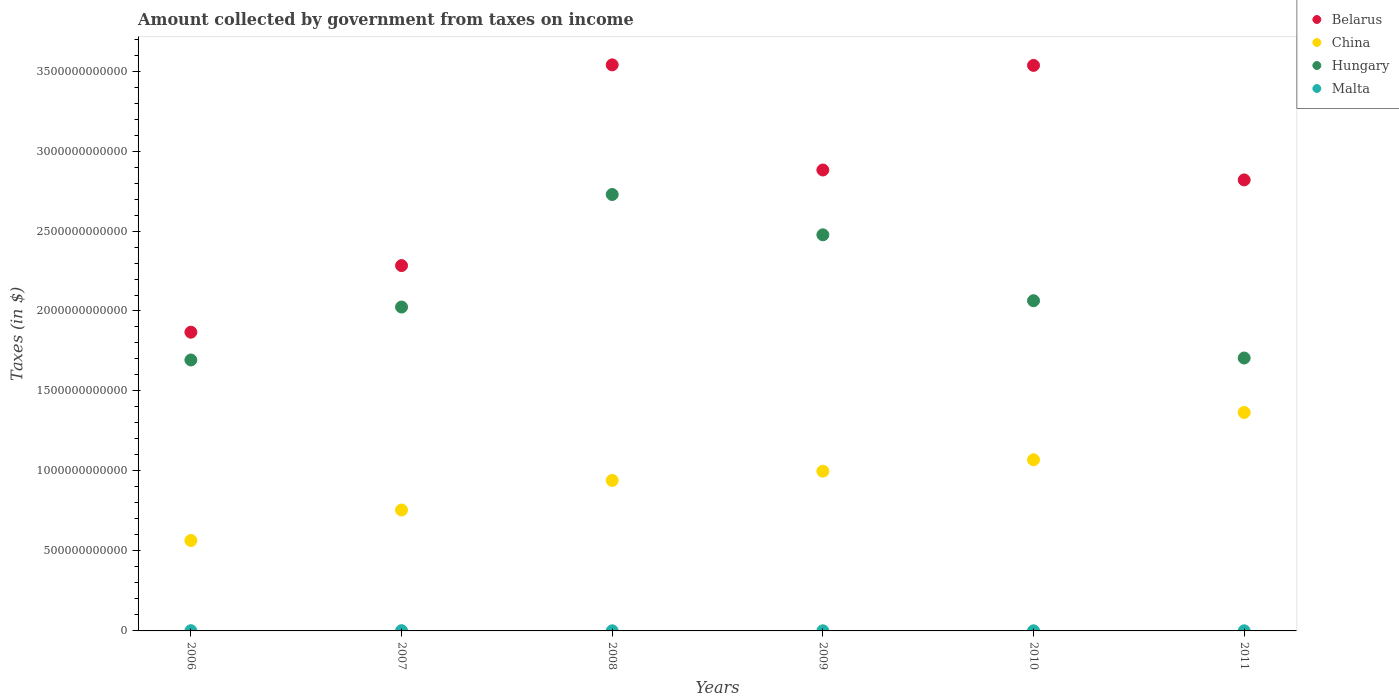What is the amount collected by government from taxes on income in Hungary in 2008?
Your answer should be very brief. 2.73e+12. Across all years, what is the maximum amount collected by government from taxes on income in Hungary?
Provide a succinct answer. 2.73e+12. Across all years, what is the minimum amount collected by government from taxes on income in Hungary?
Your answer should be very brief. 1.69e+12. In which year was the amount collected by government from taxes on income in Belarus minimum?
Your answer should be very brief. 2006. What is the total amount collected by government from taxes on income in Malta in the graph?
Offer a very short reply. 6.03e+09. What is the difference between the amount collected by government from taxes on income in China in 2006 and that in 2008?
Provide a short and direct response. -3.76e+11. What is the difference between the amount collected by government from taxes on income in Hungary in 2011 and the amount collected by government from taxes on income in China in 2008?
Offer a very short reply. 7.65e+11. What is the average amount collected by government from taxes on income in China per year?
Your answer should be compact. 9.49e+11. In the year 2006, what is the difference between the amount collected by government from taxes on income in Malta and amount collected by government from taxes on income in Belarus?
Offer a terse response. -1.87e+12. What is the ratio of the amount collected by government from taxes on income in Hungary in 2006 to that in 2011?
Your answer should be compact. 0.99. Is the difference between the amount collected by government from taxes on income in Malta in 2007 and 2010 greater than the difference between the amount collected by government from taxes on income in Belarus in 2007 and 2010?
Give a very brief answer. Yes. What is the difference between the highest and the second highest amount collected by government from taxes on income in Belarus?
Your response must be concise. 3.34e+09. What is the difference between the highest and the lowest amount collected by government from taxes on income in China?
Your answer should be very brief. 8.00e+11. Is the sum of the amount collected by government from taxes on income in Malta in 2007 and 2010 greater than the maximum amount collected by government from taxes on income in Belarus across all years?
Offer a very short reply. No. Is the amount collected by government from taxes on income in Hungary strictly less than the amount collected by government from taxes on income in Malta over the years?
Provide a short and direct response. No. How many dotlines are there?
Keep it short and to the point. 4. What is the difference between two consecutive major ticks on the Y-axis?
Give a very brief answer. 5.00e+11. Does the graph contain any zero values?
Offer a terse response. No. How are the legend labels stacked?
Your response must be concise. Vertical. What is the title of the graph?
Offer a very short reply. Amount collected by government from taxes on income. Does "Middle income" appear as one of the legend labels in the graph?
Your answer should be compact. No. What is the label or title of the Y-axis?
Ensure brevity in your answer.  Taxes (in $). What is the Taxes (in $) in Belarus in 2006?
Keep it short and to the point. 1.87e+12. What is the Taxes (in $) in China in 2006?
Ensure brevity in your answer.  5.65e+11. What is the Taxes (in $) of Hungary in 2006?
Keep it short and to the point. 1.69e+12. What is the Taxes (in $) in Malta in 2006?
Your answer should be compact. 1.36e+09. What is the Taxes (in $) in Belarus in 2007?
Offer a terse response. 2.28e+12. What is the Taxes (in $) of China in 2007?
Offer a terse response. 7.56e+11. What is the Taxes (in $) in Hungary in 2007?
Your response must be concise. 2.02e+12. What is the Taxes (in $) of Malta in 2007?
Provide a succinct answer. 1.61e+09. What is the Taxes (in $) in Belarus in 2008?
Keep it short and to the point. 3.54e+12. What is the Taxes (in $) of China in 2008?
Offer a very short reply. 9.41e+11. What is the Taxes (in $) in Hungary in 2008?
Ensure brevity in your answer.  2.73e+12. What is the Taxes (in $) of Malta in 2008?
Make the answer very short. 7.17e+08. What is the Taxes (in $) of Belarus in 2009?
Keep it short and to the point. 2.88e+12. What is the Taxes (in $) of China in 2009?
Ensure brevity in your answer.  9.99e+11. What is the Taxes (in $) in Hungary in 2009?
Ensure brevity in your answer.  2.48e+12. What is the Taxes (in $) of Malta in 2009?
Offer a very short reply. 7.59e+08. What is the Taxes (in $) of Belarus in 2010?
Provide a succinct answer. 3.54e+12. What is the Taxes (in $) in China in 2010?
Make the answer very short. 1.07e+12. What is the Taxes (in $) in Hungary in 2010?
Give a very brief answer. 2.06e+12. What is the Taxes (in $) in Malta in 2010?
Your answer should be very brief. 7.70e+08. What is the Taxes (in $) in Belarus in 2011?
Make the answer very short. 2.82e+12. What is the Taxes (in $) in China in 2011?
Give a very brief answer. 1.37e+12. What is the Taxes (in $) of Hungary in 2011?
Make the answer very short. 1.71e+12. What is the Taxes (in $) of Malta in 2011?
Provide a short and direct response. 8.11e+08. Across all years, what is the maximum Taxes (in $) in Belarus?
Give a very brief answer. 3.54e+12. Across all years, what is the maximum Taxes (in $) of China?
Your answer should be very brief. 1.37e+12. Across all years, what is the maximum Taxes (in $) of Hungary?
Keep it short and to the point. 2.73e+12. Across all years, what is the maximum Taxes (in $) of Malta?
Keep it short and to the point. 1.61e+09. Across all years, what is the minimum Taxes (in $) in Belarus?
Provide a succinct answer. 1.87e+12. Across all years, what is the minimum Taxes (in $) of China?
Make the answer very short. 5.65e+11. Across all years, what is the minimum Taxes (in $) in Hungary?
Make the answer very short. 1.69e+12. Across all years, what is the minimum Taxes (in $) of Malta?
Provide a succinct answer. 7.17e+08. What is the total Taxes (in $) in Belarus in the graph?
Offer a terse response. 1.69e+13. What is the total Taxes (in $) of China in the graph?
Offer a terse response. 5.70e+12. What is the total Taxes (in $) of Hungary in the graph?
Ensure brevity in your answer.  1.27e+13. What is the total Taxes (in $) of Malta in the graph?
Keep it short and to the point. 6.03e+09. What is the difference between the Taxes (in $) of Belarus in 2006 and that in 2007?
Offer a terse response. -4.16e+11. What is the difference between the Taxes (in $) of China in 2006 and that in 2007?
Keep it short and to the point. -1.91e+11. What is the difference between the Taxes (in $) in Hungary in 2006 and that in 2007?
Give a very brief answer. -3.31e+11. What is the difference between the Taxes (in $) of Malta in 2006 and that in 2007?
Your answer should be compact. -2.51e+08. What is the difference between the Taxes (in $) of Belarus in 2006 and that in 2008?
Your response must be concise. -1.67e+12. What is the difference between the Taxes (in $) in China in 2006 and that in 2008?
Give a very brief answer. -3.76e+11. What is the difference between the Taxes (in $) in Hungary in 2006 and that in 2008?
Offer a terse response. -1.03e+12. What is the difference between the Taxes (in $) of Malta in 2006 and that in 2008?
Provide a short and direct response. 6.43e+08. What is the difference between the Taxes (in $) in Belarus in 2006 and that in 2009?
Give a very brief answer. -1.01e+12. What is the difference between the Taxes (in $) of China in 2006 and that in 2009?
Provide a short and direct response. -4.33e+11. What is the difference between the Taxes (in $) in Hungary in 2006 and that in 2009?
Offer a terse response. -7.82e+11. What is the difference between the Taxes (in $) of Malta in 2006 and that in 2009?
Your response must be concise. 6.01e+08. What is the difference between the Taxes (in $) in Belarus in 2006 and that in 2010?
Your answer should be compact. -1.67e+12. What is the difference between the Taxes (in $) of China in 2006 and that in 2010?
Your answer should be compact. -5.05e+11. What is the difference between the Taxes (in $) of Hungary in 2006 and that in 2010?
Provide a short and direct response. -3.70e+11. What is the difference between the Taxes (in $) of Malta in 2006 and that in 2010?
Ensure brevity in your answer.  5.90e+08. What is the difference between the Taxes (in $) of Belarus in 2006 and that in 2011?
Provide a short and direct response. -9.52e+11. What is the difference between the Taxes (in $) in China in 2006 and that in 2011?
Your answer should be very brief. -8.00e+11. What is the difference between the Taxes (in $) in Hungary in 2006 and that in 2011?
Provide a succinct answer. -1.23e+1. What is the difference between the Taxes (in $) in Malta in 2006 and that in 2011?
Your answer should be compact. 5.50e+08. What is the difference between the Taxes (in $) in Belarus in 2007 and that in 2008?
Your answer should be compact. -1.25e+12. What is the difference between the Taxes (in $) in China in 2007 and that in 2008?
Offer a very short reply. -1.85e+11. What is the difference between the Taxes (in $) in Hungary in 2007 and that in 2008?
Ensure brevity in your answer.  -7.04e+11. What is the difference between the Taxes (in $) of Malta in 2007 and that in 2008?
Make the answer very short. 8.94e+08. What is the difference between the Taxes (in $) of Belarus in 2007 and that in 2009?
Offer a terse response. -5.97e+11. What is the difference between the Taxes (in $) of China in 2007 and that in 2009?
Your response must be concise. -2.43e+11. What is the difference between the Taxes (in $) of Hungary in 2007 and that in 2009?
Ensure brevity in your answer.  -4.52e+11. What is the difference between the Taxes (in $) of Malta in 2007 and that in 2009?
Ensure brevity in your answer.  8.52e+08. What is the difference between the Taxes (in $) in Belarus in 2007 and that in 2010?
Your response must be concise. -1.25e+12. What is the difference between the Taxes (in $) of China in 2007 and that in 2010?
Keep it short and to the point. -3.14e+11. What is the difference between the Taxes (in $) of Hungary in 2007 and that in 2010?
Provide a short and direct response. -3.95e+1. What is the difference between the Taxes (in $) of Malta in 2007 and that in 2010?
Keep it short and to the point. 8.41e+08. What is the difference between the Taxes (in $) in Belarus in 2007 and that in 2011?
Your answer should be very brief. -5.36e+11. What is the difference between the Taxes (in $) of China in 2007 and that in 2011?
Your answer should be very brief. -6.10e+11. What is the difference between the Taxes (in $) of Hungary in 2007 and that in 2011?
Offer a very short reply. 3.19e+11. What is the difference between the Taxes (in $) of Malta in 2007 and that in 2011?
Make the answer very short. 8.00e+08. What is the difference between the Taxes (in $) in Belarus in 2008 and that in 2009?
Offer a terse response. 6.57e+11. What is the difference between the Taxes (in $) in China in 2008 and that in 2009?
Your response must be concise. -5.78e+1. What is the difference between the Taxes (in $) in Hungary in 2008 and that in 2009?
Ensure brevity in your answer.  2.52e+11. What is the difference between the Taxes (in $) of Malta in 2008 and that in 2009?
Give a very brief answer. -4.20e+07. What is the difference between the Taxes (in $) in Belarus in 2008 and that in 2010?
Provide a succinct answer. 3.34e+09. What is the difference between the Taxes (in $) of China in 2008 and that in 2010?
Your answer should be compact. -1.29e+11. What is the difference between the Taxes (in $) in Hungary in 2008 and that in 2010?
Make the answer very short. 6.64e+11. What is the difference between the Taxes (in $) of Malta in 2008 and that in 2010?
Ensure brevity in your answer.  -5.29e+07. What is the difference between the Taxes (in $) in Belarus in 2008 and that in 2011?
Your response must be concise. 7.19e+11. What is the difference between the Taxes (in $) in China in 2008 and that in 2011?
Your response must be concise. -4.25e+11. What is the difference between the Taxes (in $) in Hungary in 2008 and that in 2011?
Offer a very short reply. 1.02e+12. What is the difference between the Taxes (in $) in Malta in 2008 and that in 2011?
Your response must be concise. -9.34e+07. What is the difference between the Taxes (in $) of Belarus in 2009 and that in 2010?
Offer a very short reply. -6.54e+11. What is the difference between the Taxes (in $) in China in 2009 and that in 2010?
Offer a terse response. -7.12e+1. What is the difference between the Taxes (in $) in Hungary in 2009 and that in 2010?
Your response must be concise. 4.12e+11. What is the difference between the Taxes (in $) in Malta in 2009 and that in 2010?
Make the answer very short. -1.09e+07. What is the difference between the Taxes (in $) of Belarus in 2009 and that in 2011?
Your response must be concise. 6.19e+1. What is the difference between the Taxes (in $) of China in 2009 and that in 2011?
Give a very brief answer. -3.67e+11. What is the difference between the Taxes (in $) in Hungary in 2009 and that in 2011?
Your answer should be very brief. 7.70e+11. What is the difference between the Taxes (in $) in Malta in 2009 and that in 2011?
Make the answer very short. -5.14e+07. What is the difference between the Taxes (in $) in Belarus in 2010 and that in 2011?
Offer a terse response. 7.16e+11. What is the difference between the Taxes (in $) in China in 2010 and that in 2011?
Provide a succinct answer. -2.96e+11. What is the difference between the Taxes (in $) in Hungary in 2010 and that in 2011?
Offer a very short reply. 3.58e+11. What is the difference between the Taxes (in $) of Malta in 2010 and that in 2011?
Give a very brief answer. -4.05e+07. What is the difference between the Taxes (in $) of Belarus in 2006 and the Taxes (in $) of China in 2007?
Offer a very short reply. 1.11e+12. What is the difference between the Taxes (in $) of Belarus in 2006 and the Taxes (in $) of Hungary in 2007?
Keep it short and to the point. -1.57e+11. What is the difference between the Taxes (in $) in Belarus in 2006 and the Taxes (in $) in Malta in 2007?
Provide a succinct answer. 1.87e+12. What is the difference between the Taxes (in $) of China in 2006 and the Taxes (in $) of Hungary in 2007?
Offer a very short reply. -1.46e+12. What is the difference between the Taxes (in $) of China in 2006 and the Taxes (in $) of Malta in 2007?
Ensure brevity in your answer.  5.64e+11. What is the difference between the Taxes (in $) in Hungary in 2006 and the Taxes (in $) in Malta in 2007?
Ensure brevity in your answer.  1.69e+12. What is the difference between the Taxes (in $) of Belarus in 2006 and the Taxes (in $) of China in 2008?
Your answer should be very brief. 9.27e+11. What is the difference between the Taxes (in $) of Belarus in 2006 and the Taxes (in $) of Hungary in 2008?
Make the answer very short. -8.61e+11. What is the difference between the Taxes (in $) in Belarus in 2006 and the Taxes (in $) in Malta in 2008?
Provide a short and direct response. 1.87e+12. What is the difference between the Taxes (in $) in China in 2006 and the Taxes (in $) in Hungary in 2008?
Your answer should be very brief. -2.16e+12. What is the difference between the Taxes (in $) in China in 2006 and the Taxes (in $) in Malta in 2008?
Your response must be concise. 5.65e+11. What is the difference between the Taxes (in $) in Hungary in 2006 and the Taxes (in $) in Malta in 2008?
Keep it short and to the point. 1.69e+12. What is the difference between the Taxes (in $) in Belarus in 2006 and the Taxes (in $) in China in 2009?
Your answer should be compact. 8.69e+11. What is the difference between the Taxes (in $) of Belarus in 2006 and the Taxes (in $) of Hungary in 2009?
Ensure brevity in your answer.  -6.09e+11. What is the difference between the Taxes (in $) of Belarus in 2006 and the Taxes (in $) of Malta in 2009?
Offer a terse response. 1.87e+12. What is the difference between the Taxes (in $) in China in 2006 and the Taxes (in $) in Hungary in 2009?
Make the answer very short. -1.91e+12. What is the difference between the Taxes (in $) of China in 2006 and the Taxes (in $) of Malta in 2009?
Keep it short and to the point. 5.65e+11. What is the difference between the Taxes (in $) of Hungary in 2006 and the Taxes (in $) of Malta in 2009?
Give a very brief answer. 1.69e+12. What is the difference between the Taxes (in $) in Belarus in 2006 and the Taxes (in $) in China in 2010?
Provide a short and direct response. 7.98e+11. What is the difference between the Taxes (in $) in Belarus in 2006 and the Taxes (in $) in Hungary in 2010?
Ensure brevity in your answer.  -1.97e+11. What is the difference between the Taxes (in $) in Belarus in 2006 and the Taxes (in $) in Malta in 2010?
Provide a short and direct response. 1.87e+12. What is the difference between the Taxes (in $) in China in 2006 and the Taxes (in $) in Hungary in 2010?
Make the answer very short. -1.50e+12. What is the difference between the Taxes (in $) in China in 2006 and the Taxes (in $) in Malta in 2010?
Your answer should be compact. 5.64e+11. What is the difference between the Taxes (in $) in Hungary in 2006 and the Taxes (in $) in Malta in 2010?
Make the answer very short. 1.69e+12. What is the difference between the Taxes (in $) in Belarus in 2006 and the Taxes (in $) in China in 2011?
Offer a terse response. 5.02e+11. What is the difference between the Taxes (in $) of Belarus in 2006 and the Taxes (in $) of Hungary in 2011?
Provide a succinct answer. 1.61e+11. What is the difference between the Taxes (in $) in Belarus in 2006 and the Taxes (in $) in Malta in 2011?
Your answer should be compact. 1.87e+12. What is the difference between the Taxes (in $) of China in 2006 and the Taxes (in $) of Hungary in 2011?
Your answer should be compact. -1.14e+12. What is the difference between the Taxes (in $) in China in 2006 and the Taxes (in $) in Malta in 2011?
Offer a terse response. 5.64e+11. What is the difference between the Taxes (in $) in Hungary in 2006 and the Taxes (in $) in Malta in 2011?
Your answer should be compact. 1.69e+12. What is the difference between the Taxes (in $) in Belarus in 2007 and the Taxes (in $) in China in 2008?
Offer a terse response. 1.34e+12. What is the difference between the Taxes (in $) in Belarus in 2007 and the Taxes (in $) in Hungary in 2008?
Provide a short and direct response. -4.44e+11. What is the difference between the Taxes (in $) in Belarus in 2007 and the Taxes (in $) in Malta in 2008?
Offer a very short reply. 2.28e+12. What is the difference between the Taxes (in $) in China in 2007 and the Taxes (in $) in Hungary in 2008?
Your answer should be very brief. -1.97e+12. What is the difference between the Taxes (in $) in China in 2007 and the Taxes (in $) in Malta in 2008?
Provide a short and direct response. 7.55e+11. What is the difference between the Taxes (in $) of Hungary in 2007 and the Taxes (in $) of Malta in 2008?
Give a very brief answer. 2.02e+12. What is the difference between the Taxes (in $) of Belarus in 2007 and the Taxes (in $) of China in 2009?
Give a very brief answer. 1.29e+12. What is the difference between the Taxes (in $) in Belarus in 2007 and the Taxes (in $) in Hungary in 2009?
Keep it short and to the point. -1.92e+11. What is the difference between the Taxes (in $) of Belarus in 2007 and the Taxes (in $) of Malta in 2009?
Your answer should be compact. 2.28e+12. What is the difference between the Taxes (in $) of China in 2007 and the Taxes (in $) of Hungary in 2009?
Keep it short and to the point. -1.72e+12. What is the difference between the Taxes (in $) in China in 2007 and the Taxes (in $) in Malta in 2009?
Keep it short and to the point. 7.55e+11. What is the difference between the Taxes (in $) in Hungary in 2007 and the Taxes (in $) in Malta in 2009?
Your answer should be very brief. 2.02e+12. What is the difference between the Taxes (in $) in Belarus in 2007 and the Taxes (in $) in China in 2010?
Make the answer very short. 1.21e+12. What is the difference between the Taxes (in $) in Belarus in 2007 and the Taxes (in $) in Hungary in 2010?
Provide a short and direct response. 2.20e+11. What is the difference between the Taxes (in $) of Belarus in 2007 and the Taxes (in $) of Malta in 2010?
Offer a terse response. 2.28e+12. What is the difference between the Taxes (in $) in China in 2007 and the Taxes (in $) in Hungary in 2010?
Offer a terse response. -1.31e+12. What is the difference between the Taxes (in $) in China in 2007 and the Taxes (in $) in Malta in 2010?
Make the answer very short. 7.55e+11. What is the difference between the Taxes (in $) of Hungary in 2007 and the Taxes (in $) of Malta in 2010?
Keep it short and to the point. 2.02e+12. What is the difference between the Taxes (in $) in Belarus in 2007 and the Taxes (in $) in China in 2011?
Offer a very short reply. 9.18e+11. What is the difference between the Taxes (in $) in Belarus in 2007 and the Taxes (in $) in Hungary in 2011?
Your answer should be compact. 5.78e+11. What is the difference between the Taxes (in $) of Belarus in 2007 and the Taxes (in $) of Malta in 2011?
Your response must be concise. 2.28e+12. What is the difference between the Taxes (in $) in China in 2007 and the Taxes (in $) in Hungary in 2011?
Give a very brief answer. -9.50e+11. What is the difference between the Taxes (in $) in China in 2007 and the Taxes (in $) in Malta in 2011?
Ensure brevity in your answer.  7.55e+11. What is the difference between the Taxes (in $) in Hungary in 2007 and the Taxes (in $) in Malta in 2011?
Offer a terse response. 2.02e+12. What is the difference between the Taxes (in $) in Belarus in 2008 and the Taxes (in $) in China in 2009?
Keep it short and to the point. 2.54e+12. What is the difference between the Taxes (in $) of Belarus in 2008 and the Taxes (in $) of Hungary in 2009?
Give a very brief answer. 1.06e+12. What is the difference between the Taxes (in $) of Belarus in 2008 and the Taxes (in $) of Malta in 2009?
Your answer should be compact. 3.54e+12. What is the difference between the Taxes (in $) in China in 2008 and the Taxes (in $) in Hungary in 2009?
Provide a short and direct response. -1.54e+12. What is the difference between the Taxes (in $) of China in 2008 and the Taxes (in $) of Malta in 2009?
Offer a terse response. 9.40e+11. What is the difference between the Taxes (in $) of Hungary in 2008 and the Taxes (in $) of Malta in 2009?
Keep it short and to the point. 2.73e+12. What is the difference between the Taxes (in $) in Belarus in 2008 and the Taxes (in $) in China in 2010?
Ensure brevity in your answer.  2.47e+12. What is the difference between the Taxes (in $) in Belarus in 2008 and the Taxes (in $) in Hungary in 2010?
Make the answer very short. 1.47e+12. What is the difference between the Taxes (in $) in Belarus in 2008 and the Taxes (in $) in Malta in 2010?
Provide a short and direct response. 3.54e+12. What is the difference between the Taxes (in $) in China in 2008 and the Taxes (in $) in Hungary in 2010?
Make the answer very short. -1.12e+12. What is the difference between the Taxes (in $) in China in 2008 and the Taxes (in $) in Malta in 2010?
Provide a short and direct response. 9.40e+11. What is the difference between the Taxes (in $) in Hungary in 2008 and the Taxes (in $) in Malta in 2010?
Provide a short and direct response. 2.73e+12. What is the difference between the Taxes (in $) in Belarus in 2008 and the Taxes (in $) in China in 2011?
Provide a short and direct response. 2.17e+12. What is the difference between the Taxes (in $) of Belarus in 2008 and the Taxes (in $) of Hungary in 2011?
Make the answer very short. 1.83e+12. What is the difference between the Taxes (in $) of Belarus in 2008 and the Taxes (in $) of Malta in 2011?
Keep it short and to the point. 3.54e+12. What is the difference between the Taxes (in $) in China in 2008 and the Taxes (in $) in Hungary in 2011?
Your answer should be compact. -7.65e+11. What is the difference between the Taxes (in $) in China in 2008 and the Taxes (in $) in Malta in 2011?
Give a very brief answer. 9.40e+11. What is the difference between the Taxes (in $) in Hungary in 2008 and the Taxes (in $) in Malta in 2011?
Your response must be concise. 2.73e+12. What is the difference between the Taxes (in $) in Belarus in 2009 and the Taxes (in $) in China in 2010?
Ensure brevity in your answer.  1.81e+12. What is the difference between the Taxes (in $) in Belarus in 2009 and the Taxes (in $) in Hungary in 2010?
Your answer should be compact. 8.17e+11. What is the difference between the Taxes (in $) of Belarus in 2009 and the Taxes (in $) of Malta in 2010?
Provide a succinct answer. 2.88e+12. What is the difference between the Taxes (in $) of China in 2009 and the Taxes (in $) of Hungary in 2010?
Provide a succinct answer. -1.07e+12. What is the difference between the Taxes (in $) of China in 2009 and the Taxes (in $) of Malta in 2010?
Offer a very short reply. 9.98e+11. What is the difference between the Taxes (in $) of Hungary in 2009 and the Taxes (in $) of Malta in 2010?
Give a very brief answer. 2.48e+12. What is the difference between the Taxes (in $) in Belarus in 2009 and the Taxes (in $) in China in 2011?
Provide a short and direct response. 1.52e+12. What is the difference between the Taxes (in $) in Belarus in 2009 and the Taxes (in $) in Hungary in 2011?
Your answer should be very brief. 1.18e+12. What is the difference between the Taxes (in $) of Belarus in 2009 and the Taxes (in $) of Malta in 2011?
Keep it short and to the point. 2.88e+12. What is the difference between the Taxes (in $) in China in 2009 and the Taxes (in $) in Hungary in 2011?
Your answer should be very brief. -7.08e+11. What is the difference between the Taxes (in $) of China in 2009 and the Taxes (in $) of Malta in 2011?
Offer a terse response. 9.98e+11. What is the difference between the Taxes (in $) of Hungary in 2009 and the Taxes (in $) of Malta in 2011?
Give a very brief answer. 2.48e+12. What is the difference between the Taxes (in $) in Belarus in 2010 and the Taxes (in $) in China in 2011?
Give a very brief answer. 2.17e+12. What is the difference between the Taxes (in $) of Belarus in 2010 and the Taxes (in $) of Hungary in 2011?
Give a very brief answer. 1.83e+12. What is the difference between the Taxes (in $) of Belarus in 2010 and the Taxes (in $) of Malta in 2011?
Your response must be concise. 3.53e+12. What is the difference between the Taxes (in $) in China in 2010 and the Taxes (in $) in Hungary in 2011?
Your response must be concise. -6.36e+11. What is the difference between the Taxes (in $) of China in 2010 and the Taxes (in $) of Malta in 2011?
Your answer should be very brief. 1.07e+12. What is the difference between the Taxes (in $) of Hungary in 2010 and the Taxes (in $) of Malta in 2011?
Keep it short and to the point. 2.06e+12. What is the average Taxes (in $) of Belarus per year?
Your answer should be compact. 2.82e+12. What is the average Taxes (in $) of China per year?
Offer a terse response. 9.49e+11. What is the average Taxes (in $) of Hungary per year?
Keep it short and to the point. 2.12e+12. What is the average Taxes (in $) in Malta per year?
Your answer should be very brief. 1.00e+09. In the year 2006, what is the difference between the Taxes (in $) in Belarus and Taxes (in $) in China?
Offer a very short reply. 1.30e+12. In the year 2006, what is the difference between the Taxes (in $) of Belarus and Taxes (in $) of Hungary?
Keep it short and to the point. 1.74e+11. In the year 2006, what is the difference between the Taxes (in $) of Belarus and Taxes (in $) of Malta?
Offer a very short reply. 1.87e+12. In the year 2006, what is the difference between the Taxes (in $) in China and Taxes (in $) in Hungary?
Provide a short and direct response. -1.13e+12. In the year 2006, what is the difference between the Taxes (in $) in China and Taxes (in $) in Malta?
Ensure brevity in your answer.  5.64e+11. In the year 2006, what is the difference between the Taxes (in $) of Hungary and Taxes (in $) of Malta?
Your answer should be compact. 1.69e+12. In the year 2007, what is the difference between the Taxes (in $) of Belarus and Taxes (in $) of China?
Provide a succinct answer. 1.53e+12. In the year 2007, what is the difference between the Taxes (in $) of Belarus and Taxes (in $) of Hungary?
Keep it short and to the point. 2.59e+11. In the year 2007, what is the difference between the Taxes (in $) in Belarus and Taxes (in $) in Malta?
Offer a terse response. 2.28e+12. In the year 2007, what is the difference between the Taxes (in $) in China and Taxes (in $) in Hungary?
Offer a terse response. -1.27e+12. In the year 2007, what is the difference between the Taxes (in $) in China and Taxes (in $) in Malta?
Your response must be concise. 7.54e+11. In the year 2007, what is the difference between the Taxes (in $) in Hungary and Taxes (in $) in Malta?
Provide a succinct answer. 2.02e+12. In the year 2008, what is the difference between the Taxes (in $) in Belarus and Taxes (in $) in China?
Keep it short and to the point. 2.60e+12. In the year 2008, what is the difference between the Taxes (in $) in Belarus and Taxes (in $) in Hungary?
Provide a short and direct response. 8.10e+11. In the year 2008, what is the difference between the Taxes (in $) of Belarus and Taxes (in $) of Malta?
Offer a very short reply. 3.54e+12. In the year 2008, what is the difference between the Taxes (in $) of China and Taxes (in $) of Hungary?
Your answer should be very brief. -1.79e+12. In the year 2008, what is the difference between the Taxes (in $) in China and Taxes (in $) in Malta?
Your answer should be compact. 9.40e+11. In the year 2008, what is the difference between the Taxes (in $) in Hungary and Taxes (in $) in Malta?
Offer a very short reply. 2.73e+12. In the year 2009, what is the difference between the Taxes (in $) of Belarus and Taxes (in $) of China?
Provide a short and direct response. 1.88e+12. In the year 2009, what is the difference between the Taxes (in $) in Belarus and Taxes (in $) in Hungary?
Keep it short and to the point. 4.05e+11. In the year 2009, what is the difference between the Taxes (in $) in Belarus and Taxes (in $) in Malta?
Your answer should be very brief. 2.88e+12. In the year 2009, what is the difference between the Taxes (in $) of China and Taxes (in $) of Hungary?
Provide a short and direct response. -1.48e+12. In the year 2009, what is the difference between the Taxes (in $) in China and Taxes (in $) in Malta?
Your answer should be compact. 9.98e+11. In the year 2009, what is the difference between the Taxes (in $) of Hungary and Taxes (in $) of Malta?
Give a very brief answer. 2.48e+12. In the year 2010, what is the difference between the Taxes (in $) in Belarus and Taxes (in $) in China?
Your answer should be very brief. 2.47e+12. In the year 2010, what is the difference between the Taxes (in $) of Belarus and Taxes (in $) of Hungary?
Give a very brief answer. 1.47e+12. In the year 2010, what is the difference between the Taxes (in $) in Belarus and Taxes (in $) in Malta?
Offer a terse response. 3.53e+12. In the year 2010, what is the difference between the Taxes (in $) in China and Taxes (in $) in Hungary?
Your answer should be compact. -9.94e+11. In the year 2010, what is the difference between the Taxes (in $) of China and Taxes (in $) of Malta?
Provide a succinct answer. 1.07e+12. In the year 2010, what is the difference between the Taxes (in $) of Hungary and Taxes (in $) of Malta?
Make the answer very short. 2.06e+12. In the year 2011, what is the difference between the Taxes (in $) in Belarus and Taxes (in $) in China?
Provide a succinct answer. 1.45e+12. In the year 2011, what is the difference between the Taxes (in $) of Belarus and Taxes (in $) of Hungary?
Make the answer very short. 1.11e+12. In the year 2011, what is the difference between the Taxes (in $) in Belarus and Taxes (in $) in Malta?
Provide a short and direct response. 2.82e+12. In the year 2011, what is the difference between the Taxes (in $) of China and Taxes (in $) of Hungary?
Keep it short and to the point. -3.40e+11. In the year 2011, what is the difference between the Taxes (in $) in China and Taxes (in $) in Malta?
Provide a succinct answer. 1.36e+12. In the year 2011, what is the difference between the Taxes (in $) in Hungary and Taxes (in $) in Malta?
Provide a succinct answer. 1.71e+12. What is the ratio of the Taxes (in $) in Belarus in 2006 to that in 2007?
Your response must be concise. 0.82. What is the ratio of the Taxes (in $) of China in 2006 to that in 2007?
Provide a short and direct response. 0.75. What is the ratio of the Taxes (in $) of Hungary in 2006 to that in 2007?
Offer a very short reply. 0.84. What is the ratio of the Taxes (in $) in Malta in 2006 to that in 2007?
Ensure brevity in your answer.  0.84. What is the ratio of the Taxes (in $) of Belarus in 2006 to that in 2008?
Make the answer very short. 0.53. What is the ratio of the Taxes (in $) of China in 2006 to that in 2008?
Your answer should be very brief. 0.6. What is the ratio of the Taxes (in $) in Hungary in 2006 to that in 2008?
Give a very brief answer. 0.62. What is the ratio of the Taxes (in $) in Malta in 2006 to that in 2008?
Provide a short and direct response. 1.9. What is the ratio of the Taxes (in $) of Belarus in 2006 to that in 2009?
Provide a succinct answer. 0.65. What is the ratio of the Taxes (in $) in China in 2006 to that in 2009?
Provide a succinct answer. 0.57. What is the ratio of the Taxes (in $) of Hungary in 2006 to that in 2009?
Give a very brief answer. 0.68. What is the ratio of the Taxes (in $) in Malta in 2006 to that in 2009?
Your answer should be very brief. 1.79. What is the ratio of the Taxes (in $) of Belarus in 2006 to that in 2010?
Keep it short and to the point. 0.53. What is the ratio of the Taxes (in $) of China in 2006 to that in 2010?
Ensure brevity in your answer.  0.53. What is the ratio of the Taxes (in $) in Hungary in 2006 to that in 2010?
Keep it short and to the point. 0.82. What is the ratio of the Taxes (in $) in Malta in 2006 to that in 2010?
Your response must be concise. 1.77. What is the ratio of the Taxes (in $) of Belarus in 2006 to that in 2011?
Offer a terse response. 0.66. What is the ratio of the Taxes (in $) in China in 2006 to that in 2011?
Give a very brief answer. 0.41. What is the ratio of the Taxes (in $) in Malta in 2006 to that in 2011?
Offer a very short reply. 1.68. What is the ratio of the Taxes (in $) in Belarus in 2007 to that in 2008?
Your response must be concise. 0.65. What is the ratio of the Taxes (in $) in China in 2007 to that in 2008?
Ensure brevity in your answer.  0.8. What is the ratio of the Taxes (in $) in Hungary in 2007 to that in 2008?
Make the answer very short. 0.74. What is the ratio of the Taxes (in $) in Malta in 2007 to that in 2008?
Provide a succinct answer. 2.25. What is the ratio of the Taxes (in $) in Belarus in 2007 to that in 2009?
Provide a succinct answer. 0.79. What is the ratio of the Taxes (in $) of China in 2007 to that in 2009?
Ensure brevity in your answer.  0.76. What is the ratio of the Taxes (in $) in Hungary in 2007 to that in 2009?
Your response must be concise. 0.82. What is the ratio of the Taxes (in $) of Malta in 2007 to that in 2009?
Your answer should be compact. 2.12. What is the ratio of the Taxes (in $) in Belarus in 2007 to that in 2010?
Your response must be concise. 0.65. What is the ratio of the Taxes (in $) of China in 2007 to that in 2010?
Ensure brevity in your answer.  0.71. What is the ratio of the Taxes (in $) of Hungary in 2007 to that in 2010?
Your answer should be compact. 0.98. What is the ratio of the Taxes (in $) of Malta in 2007 to that in 2010?
Your answer should be compact. 2.09. What is the ratio of the Taxes (in $) in Belarus in 2007 to that in 2011?
Give a very brief answer. 0.81. What is the ratio of the Taxes (in $) in China in 2007 to that in 2011?
Ensure brevity in your answer.  0.55. What is the ratio of the Taxes (in $) in Hungary in 2007 to that in 2011?
Your response must be concise. 1.19. What is the ratio of the Taxes (in $) of Malta in 2007 to that in 2011?
Your response must be concise. 1.99. What is the ratio of the Taxes (in $) of Belarus in 2008 to that in 2009?
Your response must be concise. 1.23. What is the ratio of the Taxes (in $) in China in 2008 to that in 2009?
Provide a short and direct response. 0.94. What is the ratio of the Taxes (in $) of Hungary in 2008 to that in 2009?
Your response must be concise. 1.1. What is the ratio of the Taxes (in $) of Malta in 2008 to that in 2009?
Your answer should be very brief. 0.94. What is the ratio of the Taxes (in $) of Belarus in 2008 to that in 2010?
Your answer should be very brief. 1. What is the ratio of the Taxes (in $) of China in 2008 to that in 2010?
Give a very brief answer. 0.88. What is the ratio of the Taxes (in $) of Hungary in 2008 to that in 2010?
Ensure brevity in your answer.  1.32. What is the ratio of the Taxes (in $) in Malta in 2008 to that in 2010?
Give a very brief answer. 0.93. What is the ratio of the Taxes (in $) of Belarus in 2008 to that in 2011?
Keep it short and to the point. 1.26. What is the ratio of the Taxes (in $) in China in 2008 to that in 2011?
Ensure brevity in your answer.  0.69. What is the ratio of the Taxes (in $) in Hungary in 2008 to that in 2011?
Provide a short and direct response. 1.6. What is the ratio of the Taxes (in $) in Malta in 2008 to that in 2011?
Ensure brevity in your answer.  0.88. What is the ratio of the Taxes (in $) of Belarus in 2009 to that in 2010?
Your answer should be very brief. 0.81. What is the ratio of the Taxes (in $) of China in 2009 to that in 2010?
Your response must be concise. 0.93. What is the ratio of the Taxes (in $) of Hungary in 2009 to that in 2010?
Offer a very short reply. 1.2. What is the ratio of the Taxes (in $) of Malta in 2009 to that in 2010?
Your answer should be compact. 0.99. What is the ratio of the Taxes (in $) in China in 2009 to that in 2011?
Offer a very short reply. 0.73. What is the ratio of the Taxes (in $) of Hungary in 2009 to that in 2011?
Ensure brevity in your answer.  1.45. What is the ratio of the Taxes (in $) in Malta in 2009 to that in 2011?
Your answer should be compact. 0.94. What is the ratio of the Taxes (in $) of Belarus in 2010 to that in 2011?
Ensure brevity in your answer.  1.25. What is the ratio of the Taxes (in $) of China in 2010 to that in 2011?
Offer a very short reply. 0.78. What is the ratio of the Taxes (in $) in Hungary in 2010 to that in 2011?
Your answer should be very brief. 1.21. What is the ratio of the Taxes (in $) in Malta in 2010 to that in 2011?
Make the answer very short. 0.95. What is the difference between the highest and the second highest Taxes (in $) in Belarus?
Provide a short and direct response. 3.34e+09. What is the difference between the highest and the second highest Taxes (in $) of China?
Ensure brevity in your answer.  2.96e+11. What is the difference between the highest and the second highest Taxes (in $) in Hungary?
Provide a short and direct response. 2.52e+11. What is the difference between the highest and the second highest Taxes (in $) in Malta?
Keep it short and to the point. 2.51e+08. What is the difference between the highest and the lowest Taxes (in $) in Belarus?
Offer a very short reply. 1.67e+12. What is the difference between the highest and the lowest Taxes (in $) of China?
Your answer should be compact. 8.00e+11. What is the difference between the highest and the lowest Taxes (in $) of Hungary?
Give a very brief answer. 1.03e+12. What is the difference between the highest and the lowest Taxes (in $) of Malta?
Your response must be concise. 8.94e+08. 